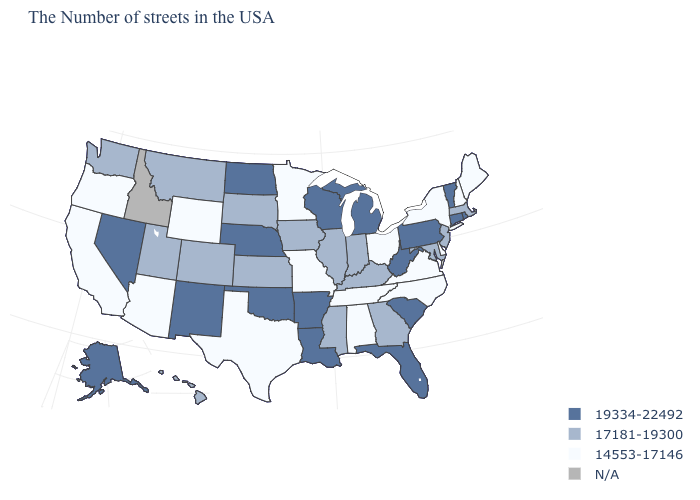What is the value of Hawaii?
Give a very brief answer. 17181-19300. Is the legend a continuous bar?
Quick response, please. No. Is the legend a continuous bar?
Quick response, please. No. What is the value of Indiana?
Quick response, please. 17181-19300. What is the value of Iowa?
Quick response, please. 17181-19300. Which states hav the highest value in the Northeast?
Quick response, please. Rhode Island, Vermont, Connecticut, Pennsylvania. Name the states that have a value in the range 17181-19300?
Quick response, please. Massachusetts, New Jersey, Maryland, Georgia, Kentucky, Indiana, Illinois, Mississippi, Iowa, Kansas, South Dakota, Colorado, Utah, Montana, Washington, Hawaii. Name the states that have a value in the range N/A?
Answer briefly. Idaho. How many symbols are there in the legend?
Be succinct. 4. Among the states that border Connecticut , does New York have the highest value?
Be succinct. No. Does the first symbol in the legend represent the smallest category?
Quick response, please. No. Name the states that have a value in the range 14553-17146?
Concise answer only. Maine, New Hampshire, New York, Delaware, Virginia, North Carolina, Ohio, Alabama, Tennessee, Missouri, Minnesota, Texas, Wyoming, Arizona, California, Oregon. Name the states that have a value in the range 17181-19300?
Answer briefly. Massachusetts, New Jersey, Maryland, Georgia, Kentucky, Indiana, Illinois, Mississippi, Iowa, Kansas, South Dakota, Colorado, Utah, Montana, Washington, Hawaii. What is the value of North Dakota?
Write a very short answer. 19334-22492. 